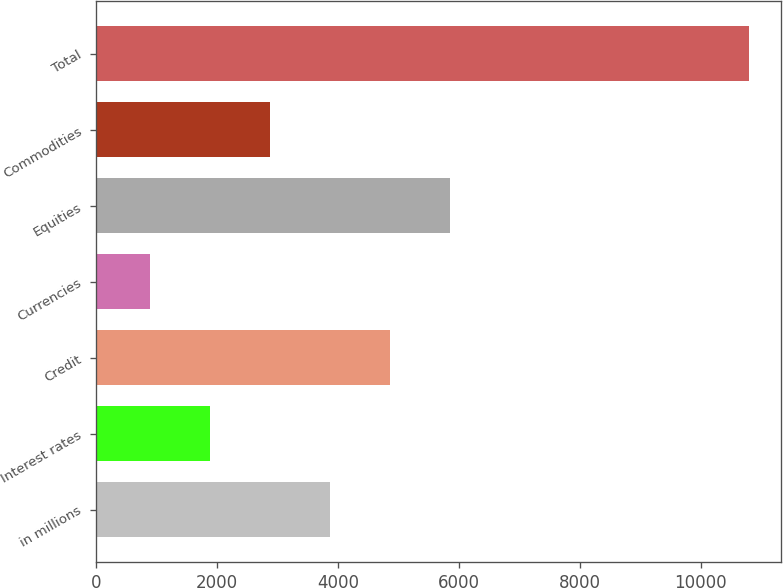Convert chart to OTSL. <chart><loc_0><loc_0><loc_500><loc_500><bar_chart><fcel>in millions<fcel>Interest rates<fcel>Credit<fcel>Currencies<fcel>Equities<fcel>Commodities<fcel>Total<nl><fcel>3868.9<fcel>1890.3<fcel>4858.2<fcel>901<fcel>5847.5<fcel>2879.6<fcel>10794<nl></chart> 